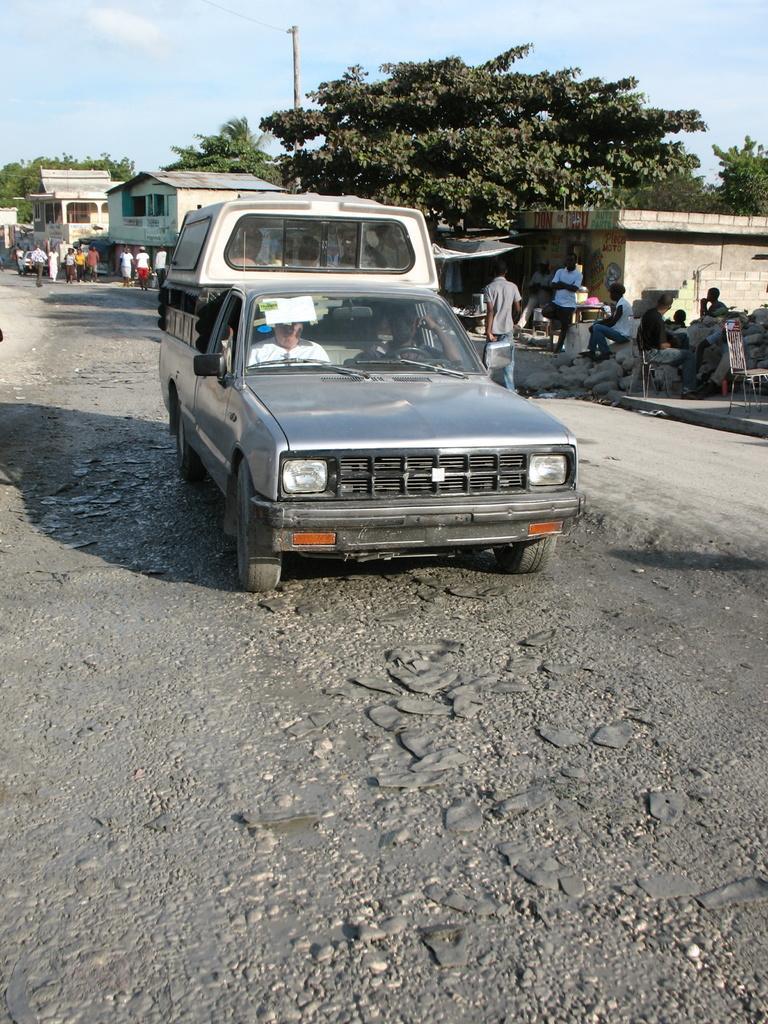In one or two sentences, can you explain what this image depicts? In this image there is a vehicle on the road. Few persons are sitting inside the vehicle. Few persons are walking on the road. Few persons are sitting on the rocks. Behind there are few houses. Behind it there are few trees and a pole. Top of image there is sky. 